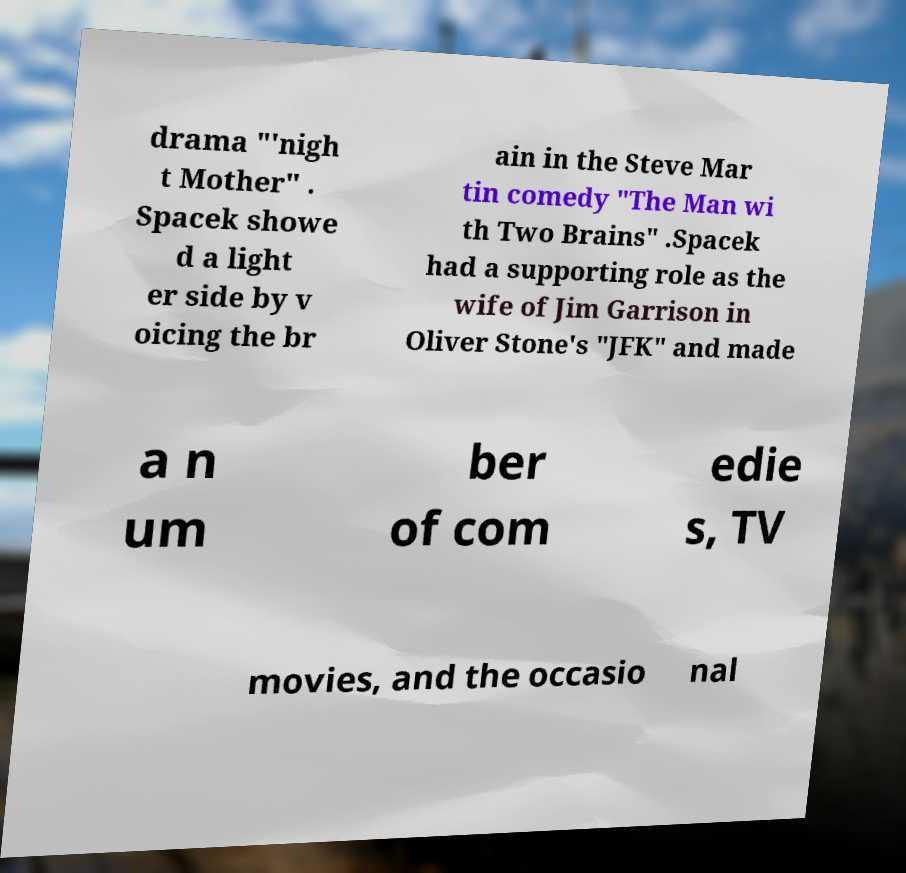Could you assist in decoding the text presented in this image and type it out clearly? drama "'nigh t Mother" . Spacek showe d a light er side by v oicing the br ain in the Steve Mar tin comedy "The Man wi th Two Brains" .Spacek had a supporting role as the wife of Jim Garrison in Oliver Stone's "JFK" and made a n um ber of com edie s, TV movies, and the occasio nal 